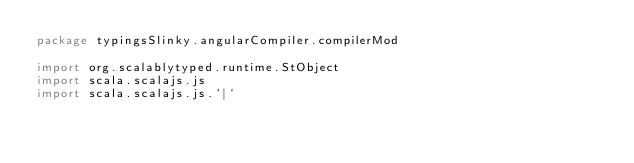<code> <loc_0><loc_0><loc_500><loc_500><_Scala_>package typingsSlinky.angularCompiler.compilerMod

import org.scalablytyped.runtime.StObject
import scala.scalajs.js
import scala.scalajs.js.`|`</code> 